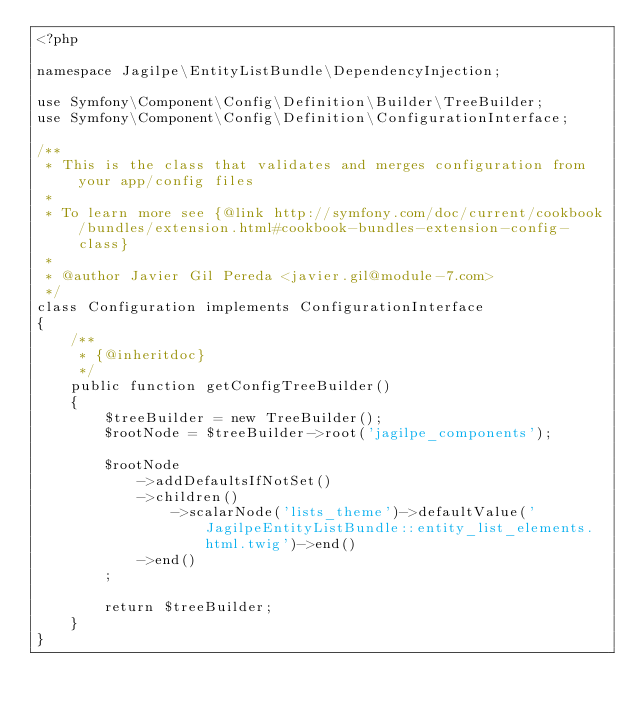<code> <loc_0><loc_0><loc_500><loc_500><_PHP_><?php

namespace Jagilpe\EntityListBundle\DependencyInjection;

use Symfony\Component\Config\Definition\Builder\TreeBuilder;
use Symfony\Component\Config\Definition\ConfigurationInterface;

/**
 * This is the class that validates and merges configuration from your app/config files
 *
 * To learn more see {@link http://symfony.com/doc/current/cookbook/bundles/extension.html#cookbook-bundles-extension-config-class}
 *
 * @author Javier Gil Pereda <javier.gil@module-7.com>
 */
class Configuration implements ConfigurationInterface
{
    /**
     * {@inheritdoc}
     */
    public function getConfigTreeBuilder()
    {
        $treeBuilder = new TreeBuilder();
        $rootNode = $treeBuilder->root('jagilpe_components');

        $rootNode
            ->addDefaultsIfNotSet()
            ->children()
                ->scalarNode('lists_theme')->defaultValue('JagilpeEntityListBundle::entity_list_elements.html.twig')->end()
            ->end()
        ;

        return $treeBuilder;
    }
}
</code> 